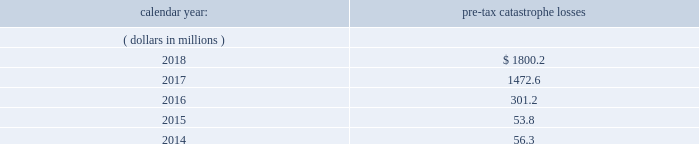Ireland .
Holdings ireland , everest dublin holdings , ireland re and ireland insurance conduct business in ireland and are subject to taxation in ireland .
Aavailable information .
The company 2019s annual reports on form 10-k , quarterly reports on form 10-q , current reports on form 8-k , proxy statements and amendments to those reports are available free of charge through the company 2019s internet website at http://www.everestre.com as soon as reasonably practicable after such reports are electronically filed with the securities and exchange commission ( the 201csec 201d ) .
Item 1a .
Risk factors in addition to the other information provided in this report , the following risk factors should be considered when evaluating an investment in our securities .
If the circumstances contemplated by the individual risk factors materialize , our business , financial condition and results of operations could be materially and adversely affected and the trading price of our common shares could decline significantly .
Risks relating to our business fluctuations in the financial markets could result in investment losses .
Prolonged and severe disruptions in the overall public and private debt and equity markets , such as occurred during 2008 , could result in significant realized and unrealized losses in our investment portfolio .
Although financial markets have significantly improved since 2008 , they could deteriorate in the future .
There could also be disruption in individual market sectors , such as occurred in the energy sector in recent years .
Such declines in the financial markets could result in significant realized and unrealized losses on investments and could have a material adverse impact on our results of operations , equity , business and insurer financial strength and debt ratings .
Our results could be adversely affected by catastrophic events .
We are exposed to unpredictable catastrophic events , including weather-related and other natural catastrophes , as well as acts of terrorism .
Any material reduction in our operating results caused by the occurrence of one or more catastrophes could inhibit our ability to pay dividends or to meet our interest and principal payment obligations .
By way of illustration , during the past five calendar years , pre-tax catastrophe losses , net of reinsurance , were as follows: .
Our losses from future catastrophic events could exceed our projections .
We use projections of possible losses from future catastrophic events of varying types and magnitudes as a strategic underwriting tool .
We use these loss projections to estimate our potential catastrophe losses in certain geographic areas and decide on the placement of retrocessional coverage or other actions to limit the extent of potential losses in a given geographic area .
These loss projections are approximations , reliant on a mix of quantitative and qualitative processes , and actual losses may exceed the projections by a material amount , resulting in a material adverse effect on our financial condition and results of operations. .
What is the total pre-tax catastrophe losses from 2014 to 2018 in miilions? 
Computations: (((301.2 + (1800.2 + 1472.6)) + 53.8) + 56.3)
Answer: 3684.1. Ireland .
Holdings ireland , everest dublin holdings , ireland re and ireland insurance conduct business in ireland and are subject to taxation in ireland .
Aavailable information .
The company 2019s annual reports on form 10-k , quarterly reports on form 10-q , current reports on form 8-k , proxy statements and amendments to those reports are available free of charge through the company 2019s internet website at http://www.everestre.com as soon as reasonably practicable after such reports are electronically filed with the securities and exchange commission ( the 201csec 201d ) .
Item 1a .
Risk factors in addition to the other information provided in this report , the following risk factors should be considered when evaluating an investment in our securities .
If the circumstances contemplated by the individual risk factors materialize , our business , financial condition and results of operations could be materially and adversely affected and the trading price of our common shares could decline significantly .
Risks relating to our business fluctuations in the financial markets could result in investment losses .
Prolonged and severe disruptions in the overall public and private debt and equity markets , such as occurred during 2008 , could result in significant realized and unrealized losses in our investment portfolio .
Although financial markets have significantly improved since 2008 , they could deteriorate in the future .
There could also be disruption in individual market sectors , such as occurred in the energy sector in recent years .
Such declines in the financial markets could result in significant realized and unrealized losses on investments and could have a material adverse impact on our results of operations , equity , business and insurer financial strength and debt ratings .
Our results could be adversely affected by catastrophic events .
We are exposed to unpredictable catastrophic events , including weather-related and other natural catastrophes , as well as acts of terrorism .
Any material reduction in our operating results caused by the occurrence of one or more catastrophes could inhibit our ability to pay dividends or to meet our interest and principal payment obligations .
By way of illustration , during the past five calendar years , pre-tax catastrophe losses , net of reinsurance , were as follows: .
Our losses from future catastrophic events could exceed our projections .
We use projections of possible losses from future catastrophic events of varying types and magnitudes as a strategic underwriting tool .
We use these loss projections to estimate our potential catastrophe losses in certain geographic areas and decide on the placement of retrocessional coverage or other actions to limit the extent of potential losses in a given geographic area .
These loss projections are approximations , reliant on a mix of quantitative and qualitative processes , and actual losses may exceed the projections by a material amount , resulting in a material adverse effect on our financial condition and results of operations. .
What is the percentage change in pre-tax catastrophe losses in 2018 compare to 2017? 
Computations: ((1800.2 - 1472.6) / 1472.6)
Answer: 0.22246. 